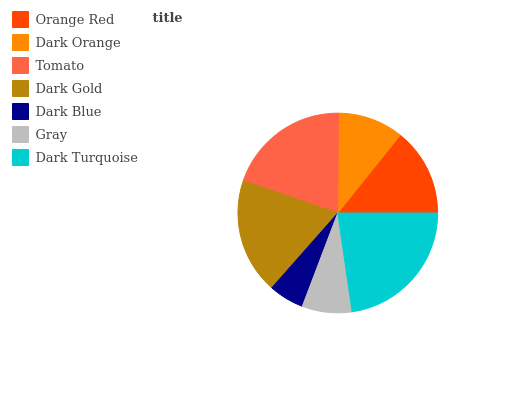Is Dark Blue the minimum?
Answer yes or no. Yes. Is Dark Turquoise the maximum?
Answer yes or no. Yes. Is Dark Orange the minimum?
Answer yes or no. No. Is Dark Orange the maximum?
Answer yes or no. No. Is Orange Red greater than Dark Orange?
Answer yes or no. Yes. Is Dark Orange less than Orange Red?
Answer yes or no. Yes. Is Dark Orange greater than Orange Red?
Answer yes or no. No. Is Orange Red less than Dark Orange?
Answer yes or no. No. Is Orange Red the high median?
Answer yes or no. Yes. Is Orange Red the low median?
Answer yes or no. Yes. Is Dark Turquoise the high median?
Answer yes or no. No. Is Dark Blue the low median?
Answer yes or no. No. 